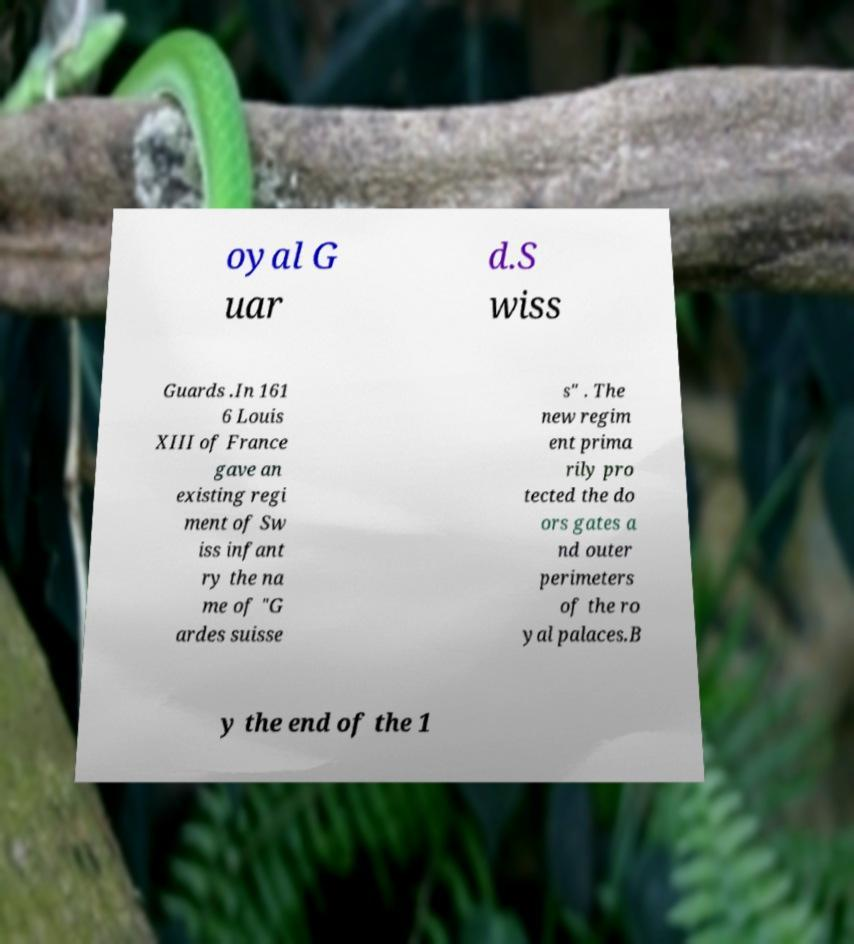There's text embedded in this image that I need extracted. Can you transcribe it verbatim? oyal G uar d.S wiss Guards .In 161 6 Louis XIII of France gave an existing regi ment of Sw iss infant ry the na me of "G ardes suisse s" . The new regim ent prima rily pro tected the do ors gates a nd outer perimeters of the ro yal palaces.B y the end of the 1 